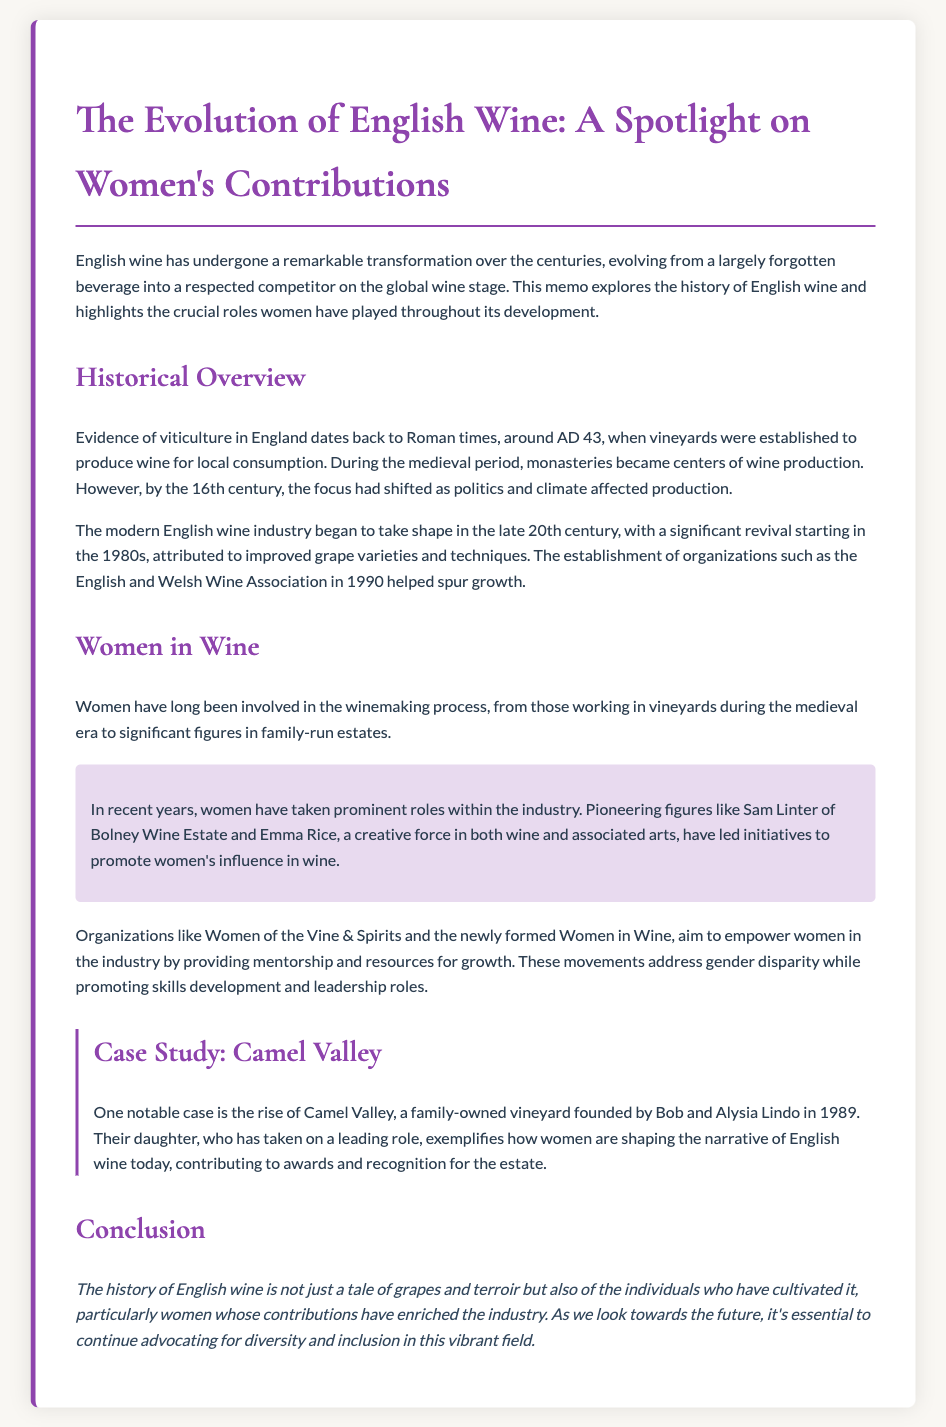What year do the roots of English viticulture trace back to? The document states that evidence of viticulture in England dates back to Roman times, around AD 43.
Answer: AD 43 What organization was established in 1990 to support the English wine industry? The document mentions the establishment of the English and Welsh Wine Association in 1990.
Answer: English and Welsh Wine Association Who is a notable figure mentioned as a pioneer in the modern English wine industry? The memo highlights Sam Linter of Bolney Wine Estate as a significant figure in the industry.
Answer: Sam Linter What is the name of the family-owned vineyard mentioned in the case study? The document refers to Camel Valley as the family-owned vineyard in the case study.
Answer: Camel Valley What role has Alysia Lindo played in Camel Valley? The document states that Alysia Lindo, along with her husband Bob, founded the vineyard, and their daughter has taken on a leading role.
Answer: Founder What is the focus of organizations like Women of the Vine & Spirits? The memo states these organizations aim to empower women in the wine industry by providing mentorship and resources for growth.
Answer: Empower women Why is it important to advocate for diversity in the English wine industry according to the conclusion? The document emphasizes that advocating for diversity and inclusion helps continue enriching the industry, particularly through women's contributions.
Answer: Enriching the industry What significant change in the English wine industry began in the 1980s? The memo indicates that a significant revival of the modern English wine industry started in the 1980s, attributed to improved grape varieties and techniques.
Answer: Revival 